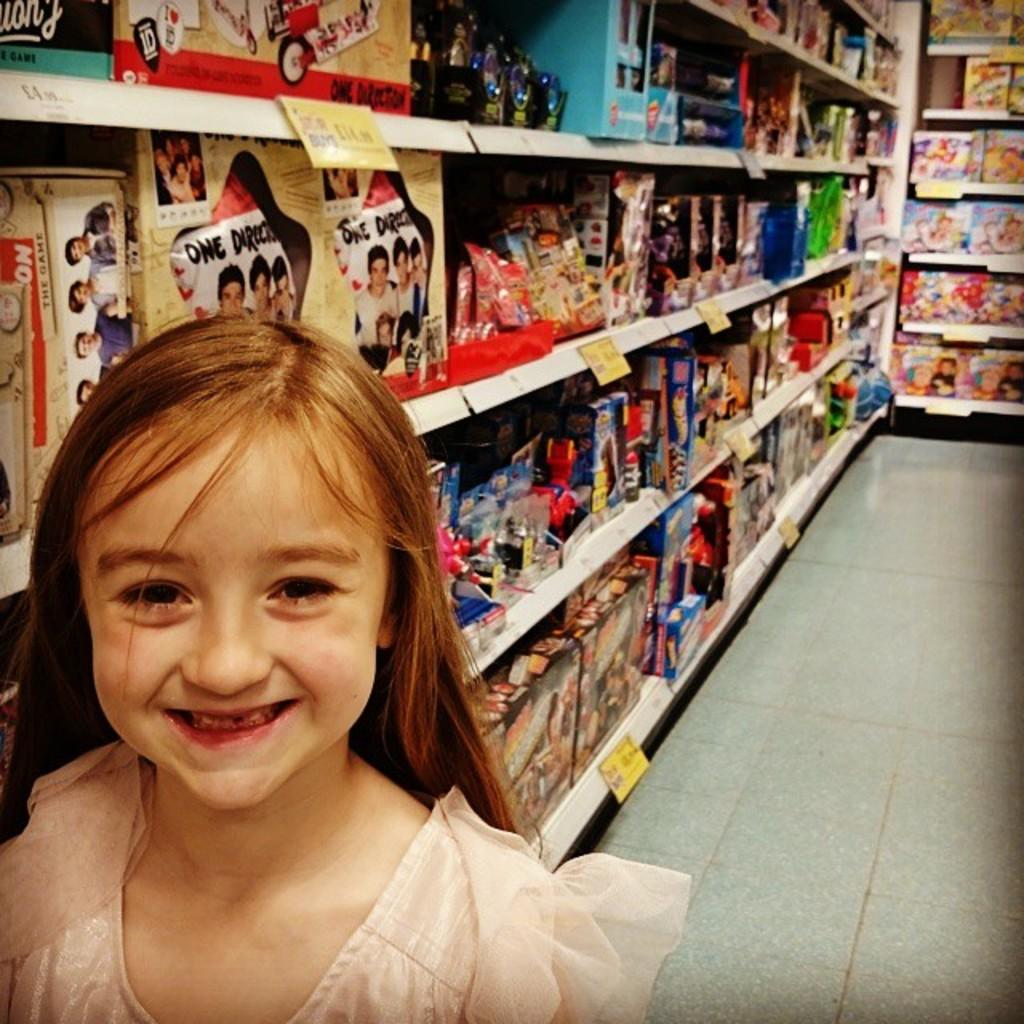What can be seen on the shelf in the image? There are items on a shelf in the image. Where is the kid located in the image? The kid is on the left side of the image. What type of spoon is the kid holding in the image? There is no spoon visible in the image, and the kid is not holding anything. What class is the kid attending in the image? There is no indication of a class or educational setting in the image. 